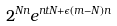Convert formula to latex. <formula><loc_0><loc_0><loc_500><loc_500>2 ^ { N n } e ^ { n t N + \epsilon ( m - N ) n }</formula> 